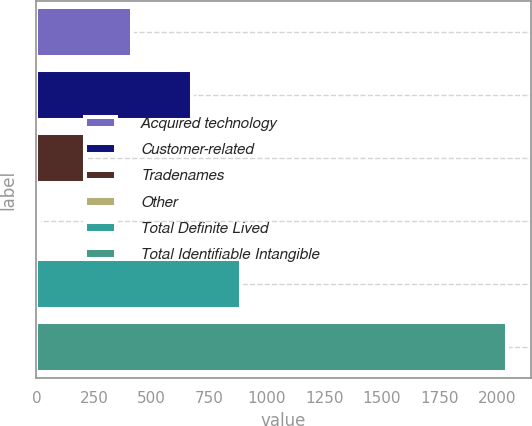Convert chart to OTSL. <chart><loc_0><loc_0><loc_500><loc_500><bar_chart><fcel>Acquired technology<fcel>Customer-related<fcel>Tradenames<fcel>Other<fcel>Total Definite Lived<fcel>Total Identifiable Intangible<nl><fcel>416.2<fcel>675<fcel>212.6<fcel>9<fcel>887<fcel>2045<nl></chart> 